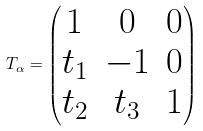Convert formula to latex. <formula><loc_0><loc_0><loc_500><loc_500>T _ { \alpha } = \begin{pmatrix} 1 & 0 & 0 \\ t _ { 1 } & - 1 & 0 \\ t _ { 2 } & t _ { 3 } & 1 \end{pmatrix}</formula> 